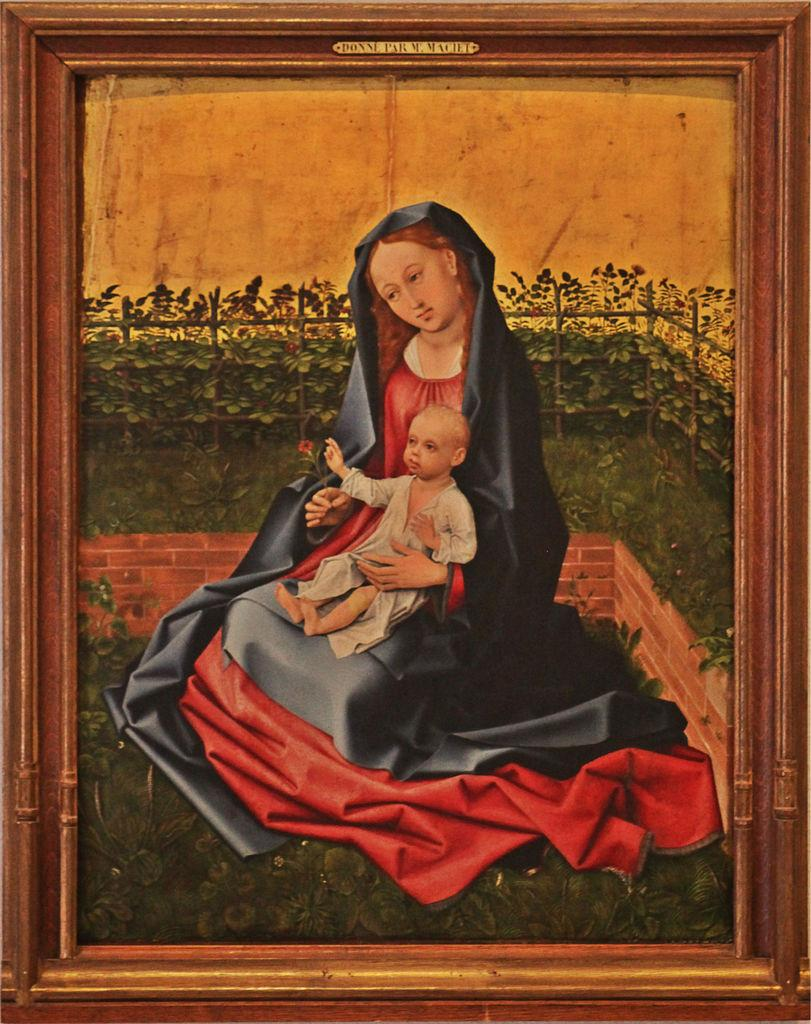<image>
Render a clear and concise summary of the photo. A framed painting of a woman holding a baby.by donne machet. 